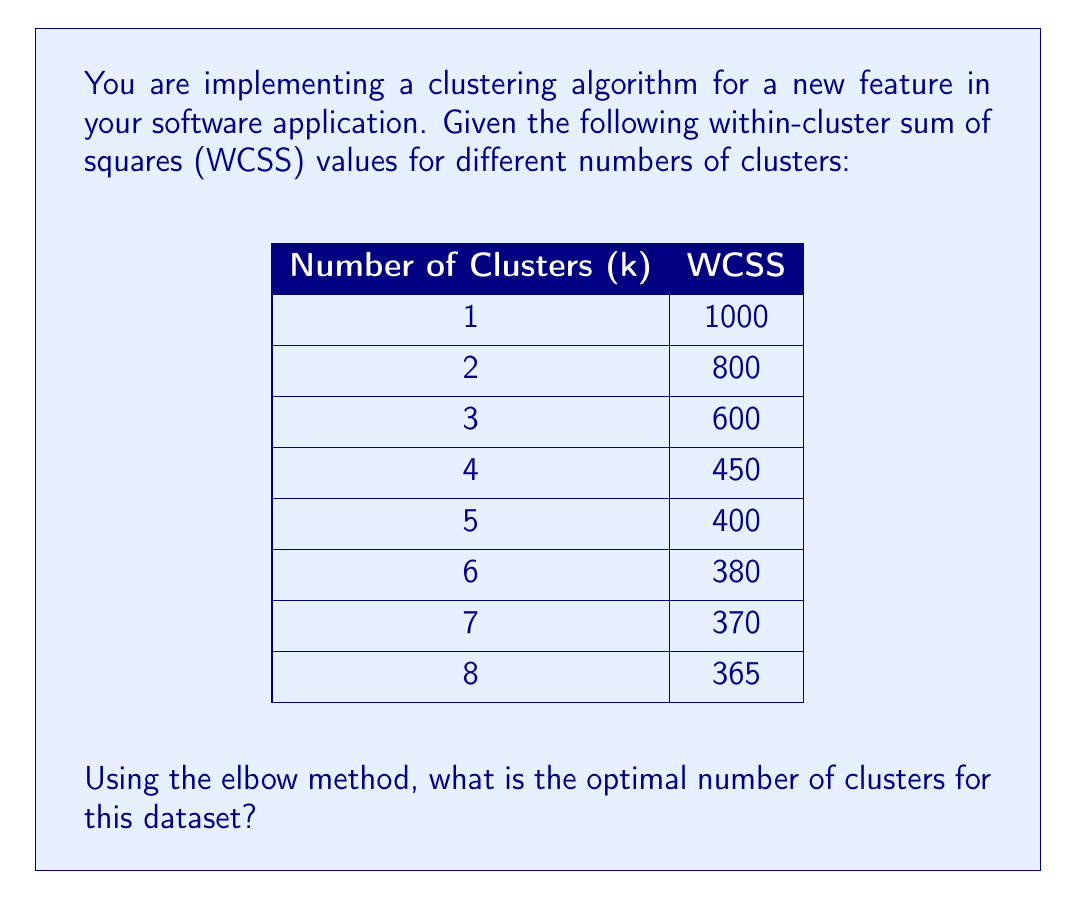Can you answer this question? To determine the optimal number of clusters using the elbow method, we need to follow these steps:

1. Plot the WCSS values against the number of clusters (k).
2. Look for the "elbow point" in the graph, where the rate of decrease in WCSS begins to level off.

Let's analyze the data:

1. For k = 1 to 2: WCSS decreases by 200 (1000 - 800)
2. For k = 2 to 3: WCSS decreases by 200 (800 - 600)
3. For k = 3 to 4: WCSS decreases by 150 (600 - 450)
4. For k = 4 to 5: WCSS decreases by 50 (450 - 400)
5. For k = 5 to 6: WCSS decreases by 20 (400 - 380)
6. For k = 6 to 7: WCSS decreases by 10 (380 - 370)
7. For k = 7 to 8: WCSS decreases by 5 (370 - 365)

We can see that the rate of decrease in WCSS slows down significantly after k = 4. The decrease from k = 4 to k = 5 is much smaller compared to the previous decreases, and it continues to diminish for higher values of k.

Therefore, the elbow point occurs at k = 4, which represents the optimal number of clusters for this dataset.

This choice balances the trade-off between minimizing the within-cluster variance and avoiding overfitting by using too many clusters.
Answer: The optimal number of clusters using the elbow method is 4. 